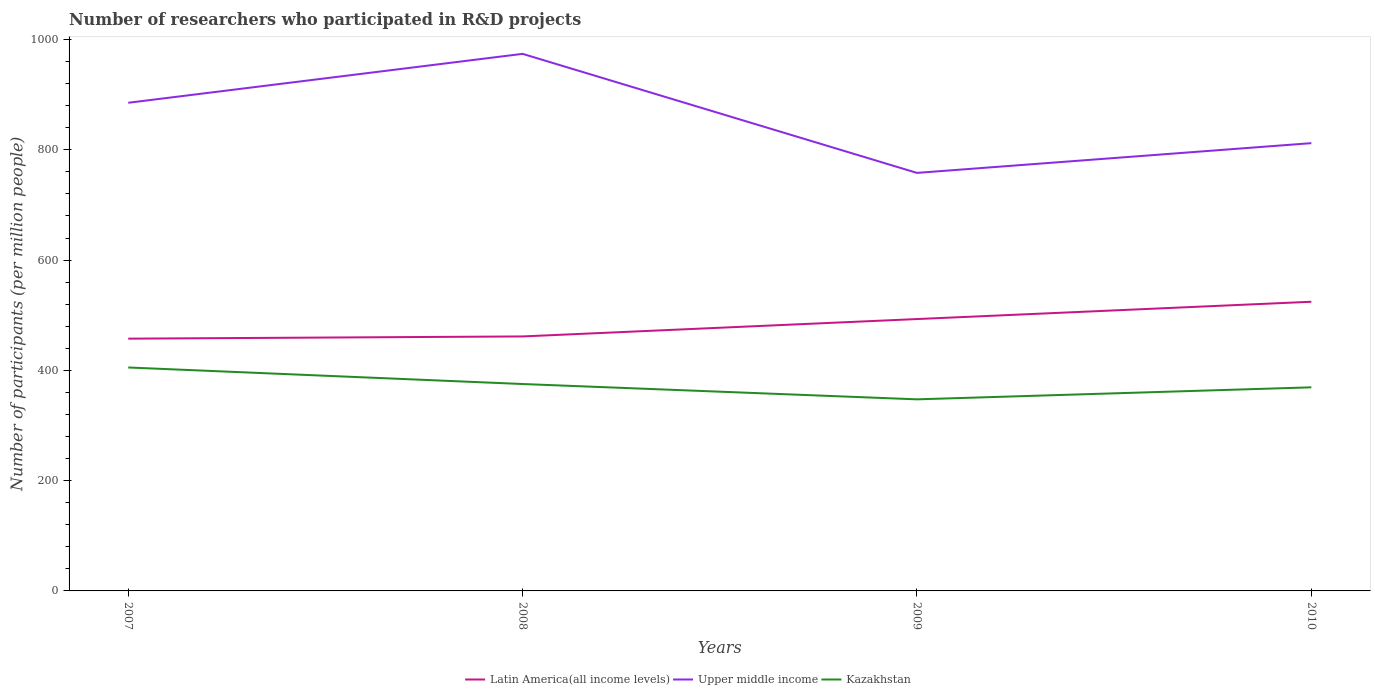How many different coloured lines are there?
Your response must be concise. 3. Does the line corresponding to Upper middle income intersect with the line corresponding to Kazakhstan?
Give a very brief answer. No. Across all years, what is the maximum number of researchers who participated in R&D projects in Upper middle income?
Offer a very short reply. 758.08. What is the total number of researchers who participated in R&D projects in Kazakhstan in the graph?
Provide a short and direct response. 29.98. What is the difference between the highest and the second highest number of researchers who participated in R&D projects in Upper middle income?
Offer a terse response. 215.88. How many years are there in the graph?
Offer a very short reply. 4. Are the values on the major ticks of Y-axis written in scientific E-notation?
Your response must be concise. No. Does the graph contain grids?
Offer a terse response. No. Where does the legend appear in the graph?
Provide a succinct answer. Bottom center. What is the title of the graph?
Keep it short and to the point. Number of researchers who participated in R&D projects. Does "Cameroon" appear as one of the legend labels in the graph?
Your answer should be very brief. No. What is the label or title of the Y-axis?
Provide a short and direct response. Number of participants (per million people). What is the Number of participants (per million people) of Latin America(all income levels) in 2007?
Give a very brief answer. 457.47. What is the Number of participants (per million people) of Upper middle income in 2007?
Ensure brevity in your answer.  885.24. What is the Number of participants (per million people) of Kazakhstan in 2007?
Give a very brief answer. 405.2. What is the Number of participants (per million people) in Latin America(all income levels) in 2008?
Your answer should be very brief. 461.5. What is the Number of participants (per million people) in Upper middle income in 2008?
Provide a short and direct response. 973.96. What is the Number of participants (per million people) of Kazakhstan in 2008?
Give a very brief answer. 375.22. What is the Number of participants (per million people) in Latin America(all income levels) in 2009?
Offer a terse response. 493.02. What is the Number of participants (per million people) of Upper middle income in 2009?
Give a very brief answer. 758.08. What is the Number of participants (per million people) in Kazakhstan in 2009?
Ensure brevity in your answer.  347.43. What is the Number of participants (per million people) in Latin America(all income levels) in 2010?
Ensure brevity in your answer.  524.4. What is the Number of participants (per million people) of Upper middle income in 2010?
Provide a succinct answer. 812.01. What is the Number of participants (per million people) of Kazakhstan in 2010?
Your answer should be very brief. 369.21. Across all years, what is the maximum Number of participants (per million people) in Latin America(all income levels)?
Offer a very short reply. 524.4. Across all years, what is the maximum Number of participants (per million people) in Upper middle income?
Keep it short and to the point. 973.96. Across all years, what is the maximum Number of participants (per million people) of Kazakhstan?
Give a very brief answer. 405.2. Across all years, what is the minimum Number of participants (per million people) of Latin America(all income levels)?
Provide a succinct answer. 457.47. Across all years, what is the minimum Number of participants (per million people) in Upper middle income?
Your response must be concise. 758.08. Across all years, what is the minimum Number of participants (per million people) in Kazakhstan?
Offer a terse response. 347.43. What is the total Number of participants (per million people) in Latin America(all income levels) in the graph?
Ensure brevity in your answer.  1936.38. What is the total Number of participants (per million people) of Upper middle income in the graph?
Keep it short and to the point. 3429.29. What is the total Number of participants (per million people) in Kazakhstan in the graph?
Keep it short and to the point. 1497.05. What is the difference between the Number of participants (per million people) of Latin America(all income levels) in 2007 and that in 2008?
Offer a very short reply. -4.03. What is the difference between the Number of participants (per million people) in Upper middle income in 2007 and that in 2008?
Your answer should be very brief. -88.72. What is the difference between the Number of participants (per million people) in Kazakhstan in 2007 and that in 2008?
Provide a short and direct response. 29.98. What is the difference between the Number of participants (per million people) of Latin America(all income levels) in 2007 and that in 2009?
Your answer should be very brief. -35.56. What is the difference between the Number of participants (per million people) in Upper middle income in 2007 and that in 2009?
Offer a very short reply. 127.16. What is the difference between the Number of participants (per million people) in Kazakhstan in 2007 and that in 2009?
Offer a terse response. 57.77. What is the difference between the Number of participants (per million people) of Latin America(all income levels) in 2007 and that in 2010?
Keep it short and to the point. -66.93. What is the difference between the Number of participants (per million people) in Upper middle income in 2007 and that in 2010?
Offer a very short reply. 73.23. What is the difference between the Number of participants (per million people) in Kazakhstan in 2007 and that in 2010?
Make the answer very short. 35.99. What is the difference between the Number of participants (per million people) in Latin America(all income levels) in 2008 and that in 2009?
Provide a short and direct response. -31.52. What is the difference between the Number of participants (per million people) in Upper middle income in 2008 and that in 2009?
Offer a very short reply. 215.88. What is the difference between the Number of participants (per million people) of Kazakhstan in 2008 and that in 2009?
Your answer should be compact. 27.79. What is the difference between the Number of participants (per million people) in Latin America(all income levels) in 2008 and that in 2010?
Your answer should be compact. -62.9. What is the difference between the Number of participants (per million people) of Upper middle income in 2008 and that in 2010?
Keep it short and to the point. 161.95. What is the difference between the Number of participants (per million people) in Kazakhstan in 2008 and that in 2010?
Provide a short and direct response. 6.01. What is the difference between the Number of participants (per million people) of Latin America(all income levels) in 2009 and that in 2010?
Keep it short and to the point. -31.37. What is the difference between the Number of participants (per million people) of Upper middle income in 2009 and that in 2010?
Provide a short and direct response. -53.94. What is the difference between the Number of participants (per million people) of Kazakhstan in 2009 and that in 2010?
Give a very brief answer. -21.78. What is the difference between the Number of participants (per million people) of Latin America(all income levels) in 2007 and the Number of participants (per million people) of Upper middle income in 2008?
Ensure brevity in your answer.  -516.5. What is the difference between the Number of participants (per million people) in Latin America(all income levels) in 2007 and the Number of participants (per million people) in Kazakhstan in 2008?
Keep it short and to the point. 82.24. What is the difference between the Number of participants (per million people) in Upper middle income in 2007 and the Number of participants (per million people) in Kazakhstan in 2008?
Provide a short and direct response. 510.02. What is the difference between the Number of participants (per million people) of Latin America(all income levels) in 2007 and the Number of participants (per million people) of Upper middle income in 2009?
Provide a succinct answer. -300.61. What is the difference between the Number of participants (per million people) of Latin America(all income levels) in 2007 and the Number of participants (per million people) of Kazakhstan in 2009?
Provide a succinct answer. 110.04. What is the difference between the Number of participants (per million people) in Upper middle income in 2007 and the Number of participants (per million people) in Kazakhstan in 2009?
Your response must be concise. 537.81. What is the difference between the Number of participants (per million people) in Latin America(all income levels) in 2007 and the Number of participants (per million people) in Upper middle income in 2010?
Provide a succinct answer. -354.55. What is the difference between the Number of participants (per million people) in Latin America(all income levels) in 2007 and the Number of participants (per million people) in Kazakhstan in 2010?
Your answer should be very brief. 88.26. What is the difference between the Number of participants (per million people) of Upper middle income in 2007 and the Number of participants (per million people) of Kazakhstan in 2010?
Give a very brief answer. 516.03. What is the difference between the Number of participants (per million people) of Latin America(all income levels) in 2008 and the Number of participants (per million people) of Upper middle income in 2009?
Ensure brevity in your answer.  -296.58. What is the difference between the Number of participants (per million people) of Latin America(all income levels) in 2008 and the Number of participants (per million people) of Kazakhstan in 2009?
Keep it short and to the point. 114.07. What is the difference between the Number of participants (per million people) in Upper middle income in 2008 and the Number of participants (per million people) in Kazakhstan in 2009?
Ensure brevity in your answer.  626.54. What is the difference between the Number of participants (per million people) in Latin America(all income levels) in 2008 and the Number of participants (per million people) in Upper middle income in 2010?
Ensure brevity in your answer.  -350.52. What is the difference between the Number of participants (per million people) in Latin America(all income levels) in 2008 and the Number of participants (per million people) in Kazakhstan in 2010?
Your answer should be compact. 92.29. What is the difference between the Number of participants (per million people) in Upper middle income in 2008 and the Number of participants (per million people) in Kazakhstan in 2010?
Provide a succinct answer. 604.76. What is the difference between the Number of participants (per million people) of Latin America(all income levels) in 2009 and the Number of participants (per million people) of Upper middle income in 2010?
Provide a succinct answer. -318.99. What is the difference between the Number of participants (per million people) of Latin America(all income levels) in 2009 and the Number of participants (per million people) of Kazakhstan in 2010?
Your answer should be very brief. 123.81. What is the difference between the Number of participants (per million people) of Upper middle income in 2009 and the Number of participants (per million people) of Kazakhstan in 2010?
Your answer should be compact. 388.87. What is the average Number of participants (per million people) in Latin America(all income levels) per year?
Provide a short and direct response. 484.1. What is the average Number of participants (per million people) of Upper middle income per year?
Your answer should be very brief. 857.32. What is the average Number of participants (per million people) of Kazakhstan per year?
Ensure brevity in your answer.  374.26. In the year 2007, what is the difference between the Number of participants (per million people) of Latin America(all income levels) and Number of participants (per million people) of Upper middle income?
Ensure brevity in your answer.  -427.78. In the year 2007, what is the difference between the Number of participants (per million people) in Latin America(all income levels) and Number of participants (per million people) in Kazakhstan?
Your response must be concise. 52.27. In the year 2007, what is the difference between the Number of participants (per million people) in Upper middle income and Number of participants (per million people) in Kazakhstan?
Your answer should be compact. 480.04. In the year 2008, what is the difference between the Number of participants (per million people) in Latin America(all income levels) and Number of participants (per million people) in Upper middle income?
Your answer should be compact. -512.46. In the year 2008, what is the difference between the Number of participants (per million people) in Latin America(all income levels) and Number of participants (per million people) in Kazakhstan?
Your response must be concise. 86.28. In the year 2008, what is the difference between the Number of participants (per million people) of Upper middle income and Number of participants (per million people) of Kazakhstan?
Offer a very short reply. 598.74. In the year 2009, what is the difference between the Number of participants (per million people) in Latin America(all income levels) and Number of participants (per million people) in Upper middle income?
Your answer should be compact. -265.06. In the year 2009, what is the difference between the Number of participants (per million people) in Latin America(all income levels) and Number of participants (per million people) in Kazakhstan?
Your response must be concise. 145.59. In the year 2009, what is the difference between the Number of participants (per million people) in Upper middle income and Number of participants (per million people) in Kazakhstan?
Keep it short and to the point. 410.65. In the year 2010, what is the difference between the Number of participants (per million people) of Latin America(all income levels) and Number of participants (per million people) of Upper middle income?
Provide a succinct answer. -287.62. In the year 2010, what is the difference between the Number of participants (per million people) in Latin America(all income levels) and Number of participants (per million people) in Kazakhstan?
Your response must be concise. 155.19. In the year 2010, what is the difference between the Number of participants (per million people) of Upper middle income and Number of participants (per million people) of Kazakhstan?
Offer a very short reply. 442.81. What is the ratio of the Number of participants (per million people) of Latin America(all income levels) in 2007 to that in 2008?
Ensure brevity in your answer.  0.99. What is the ratio of the Number of participants (per million people) of Upper middle income in 2007 to that in 2008?
Your response must be concise. 0.91. What is the ratio of the Number of participants (per million people) in Kazakhstan in 2007 to that in 2008?
Your response must be concise. 1.08. What is the ratio of the Number of participants (per million people) of Latin America(all income levels) in 2007 to that in 2009?
Give a very brief answer. 0.93. What is the ratio of the Number of participants (per million people) in Upper middle income in 2007 to that in 2009?
Ensure brevity in your answer.  1.17. What is the ratio of the Number of participants (per million people) of Kazakhstan in 2007 to that in 2009?
Keep it short and to the point. 1.17. What is the ratio of the Number of participants (per million people) of Latin America(all income levels) in 2007 to that in 2010?
Give a very brief answer. 0.87. What is the ratio of the Number of participants (per million people) in Upper middle income in 2007 to that in 2010?
Make the answer very short. 1.09. What is the ratio of the Number of participants (per million people) in Kazakhstan in 2007 to that in 2010?
Your answer should be very brief. 1.1. What is the ratio of the Number of participants (per million people) in Latin America(all income levels) in 2008 to that in 2009?
Offer a very short reply. 0.94. What is the ratio of the Number of participants (per million people) in Upper middle income in 2008 to that in 2009?
Give a very brief answer. 1.28. What is the ratio of the Number of participants (per million people) of Latin America(all income levels) in 2008 to that in 2010?
Offer a very short reply. 0.88. What is the ratio of the Number of participants (per million people) of Upper middle income in 2008 to that in 2010?
Your answer should be very brief. 1.2. What is the ratio of the Number of participants (per million people) of Kazakhstan in 2008 to that in 2010?
Your answer should be very brief. 1.02. What is the ratio of the Number of participants (per million people) in Latin America(all income levels) in 2009 to that in 2010?
Offer a terse response. 0.94. What is the ratio of the Number of participants (per million people) in Upper middle income in 2009 to that in 2010?
Offer a terse response. 0.93. What is the ratio of the Number of participants (per million people) of Kazakhstan in 2009 to that in 2010?
Your answer should be very brief. 0.94. What is the difference between the highest and the second highest Number of participants (per million people) in Latin America(all income levels)?
Your response must be concise. 31.37. What is the difference between the highest and the second highest Number of participants (per million people) of Upper middle income?
Provide a short and direct response. 88.72. What is the difference between the highest and the second highest Number of participants (per million people) of Kazakhstan?
Offer a terse response. 29.98. What is the difference between the highest and the lowest Number of participants (per million people) in Latin America(all income levels)?
Your response must be concise. 66.93. What is the difference between the highest and the lowest Number of participants (per million people) of Upper middle income?
Offer a very short reply. 215.88. What is the difference between the highest and the lowest Number of participants (per million people) of Kazakhstan?
Offer a very short reply. 57.77. 